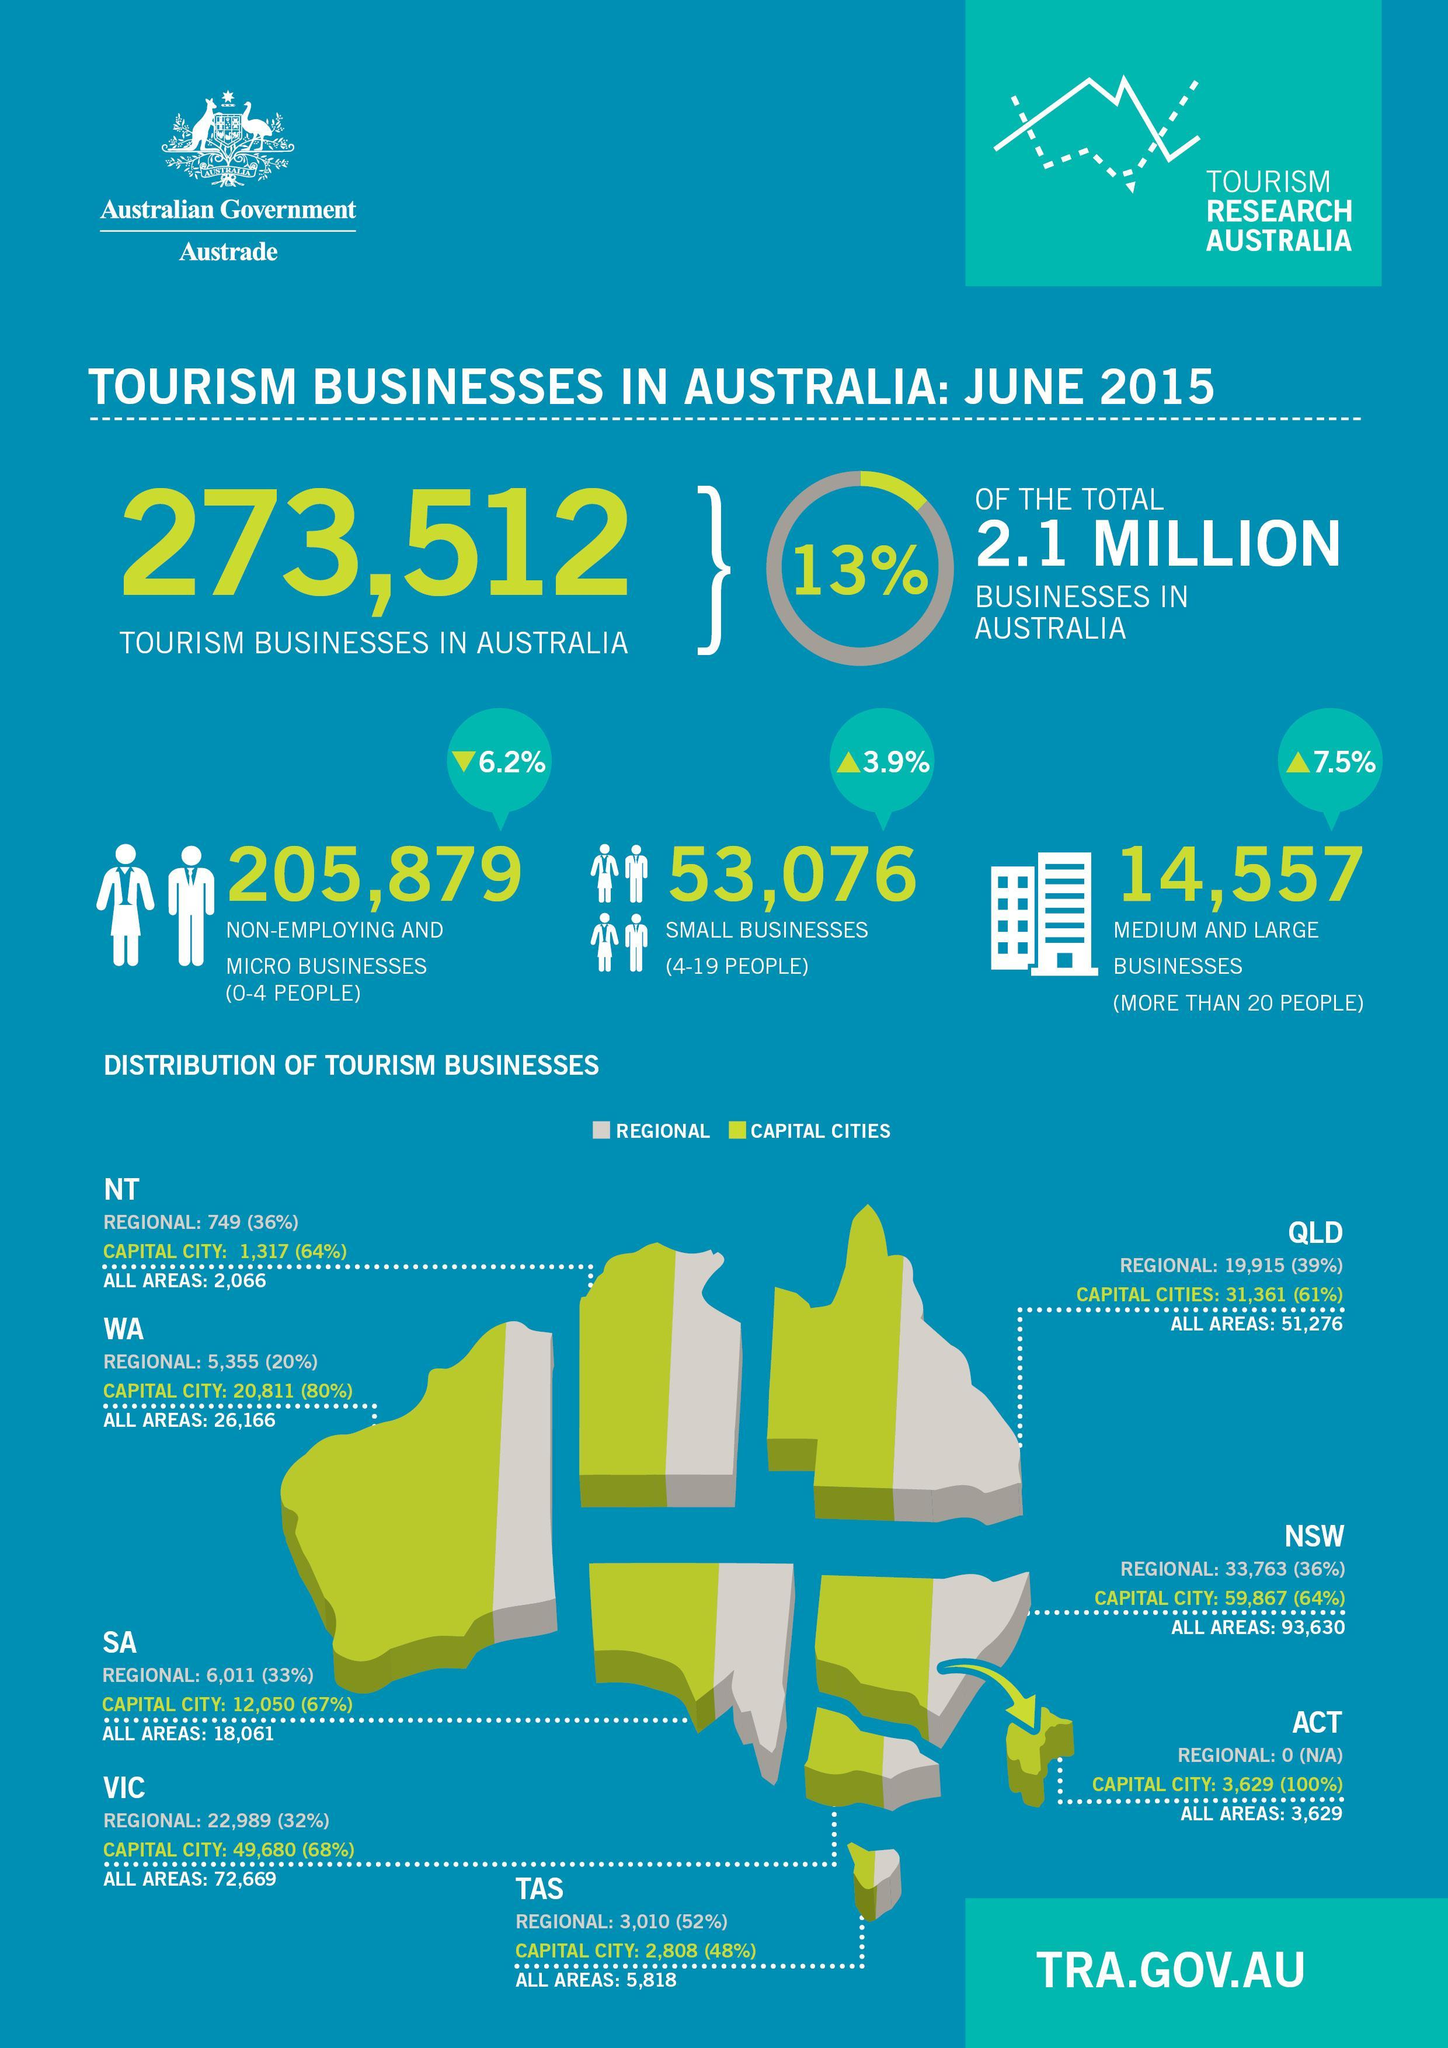What is the no of tourism businesses in all areas of QLD?
Answer the question with a short phrase. 51,276 What is the percentage of tourism businesses in Capital cities of QLD? 61% How many medium and Large tourism businesses are there in Australia? 14,557 What is the number of small business in Australia? 53,076 How many Non employing and Micro businesses are there in Australia? 205,879 How many people in Australia are doing Medium and Large businesses? more than 20 people What is the percentage of tourism businesses in Capital city of VIC? 68% 